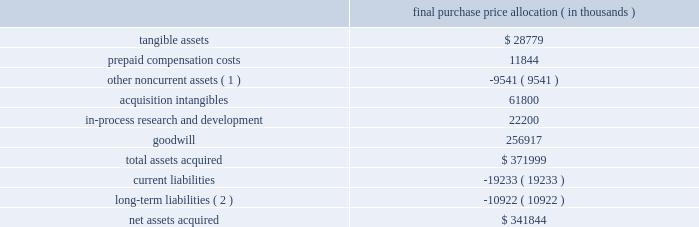Dish network corporation notes to consolidated financial statements - continued december 31 , 2008 , we recorded $ 6 million in interest and penalty expense to earnings .
Accrued interest and penalties was $ 7 million at december 31 , 2008 .
11 .
Acquisition of sling media , inc .
During october 2007 , we acquired all remaining outstanding shares ( 94% ( 94 % ) ) of sling media , inc .
( 201csling media 201d ) for cash consideration of $ 342 million , including direct transaction costs of $ 8 million .
We also exchanged sling media employee stock options for our options to purchase approximately 342000 of our common stock valued at approximately $ 16 million .
Sling media , a leading innovator in the digital- lifestyle space , was acquired to allow us to offer new products and services to our subscribers .
On january 1 , 2008 , sling media was distributed to echostar in the spin-off .
This transaction was accounted for as a purchase business combination in accordance with statement of financial accounting standards no .
141 , 201cbusiness combinations 201d ( 201csfas 141 201d ) .
The purchase consideration was allocated based on the fair values of identifiable tangible and intangible assets and liabilities as follows : purchase price allocation ( in thousands ) .
( 1 ) represents the elimination of our previously recorded 6% ( 6 % ) non-controlling interest in sling media .
( 2 ) includes $ 9 million deferred tax liability related to the acquisition intangibles .
The total $ 62 million of acquired intangible assets resulting from the sling media transaction is comprised of technology-based intangibles and trademarks totaling approximately $ 34 million with estimated weighted-average useful lives of seven years , reseller relationships totaling approximately $ 24 million with estimated weighted-average useful lives of three years and contract-based intangibles totaling approximately $ 4 million with estimated weighted-average useful lives of four years .
The in-process research and development costs of $ 22 million were expensed to general and administrative expense upon acquisition in accordance with sfas 141 .
The goodwill recorded as a result of the acquisition is not deductible for income tax purposes .
The business combination did not have a material impact on our results of operations for the year ended december 31 , 2007 and would not have materially impacted our results of operations for these periods had the business combination occurred on january 1 , 2007 .
Further , the business combination would not have had a material impact on our results of operations for the comparable period in 2006 had the business combination occurred on january 1 , 2006. .
What percentage of total assets acquired where comprised of goodwill? 
Computations: (256917 / 371999)
Answer: 0.69064. 